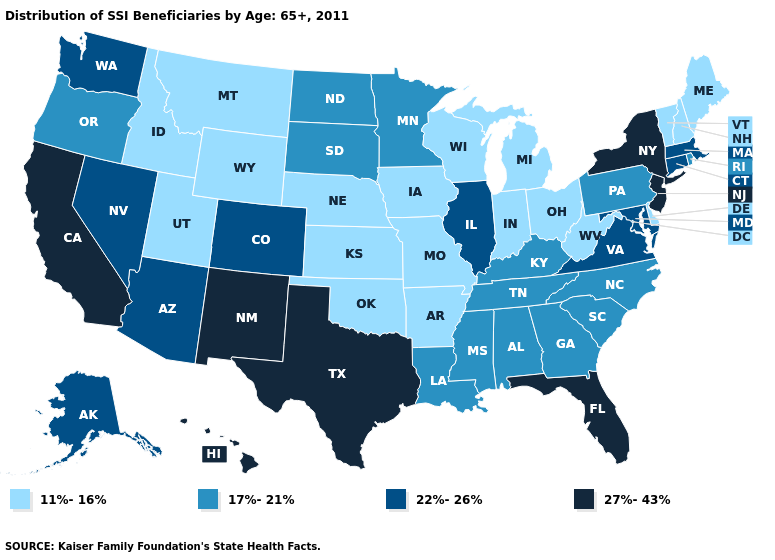What is the highest value in the USA?
Be succinct. 27%-43%. Does Oregon have a lower value than Louisiana?
Concise answer only. No. Does the first symbol in the legend represent the smallest category?
Short answer required. Yes. Name the states that have a value in the range 17%-21%?
Write a very short answer. Alabama, Georgia, Kentucky, Louisiana, Minnesota, Mississippi, North Carolina, North Dakota, Oregon, Pennsylvania, Rhode Island, South Carolina, South Dakota, Tennessee. Name the states that have a value in the range 27%-43%?
Answer briefly. California, Florida, Hawaii, New Jersey, New Mexico, New York, Texas. Name the states that have a value in the range 27%-43%?
Quick response, please. California, Florida, Hawaii, New Jersey, New Mexico, New York, Texas. What is the value of New York?
Short answer required. 27%-43%. What is the value of Oregon?
Quick response, please. 17%-21%. What is the value of Indiana?
Be succinct. 11%-16%. Does Georgia have the same value as Mississippi?
Be succinct. Yes. Does Alabama have the same value as Pennsylvania?
Concise answer only. Yes. Name the states that have a value in the range 22%-26%?
Answer briefly. Alaska, Arizona, Colorado, Connecticut, Illinois, Maryland, Massachusetts, Nevada, Virginia, Washington. Does New Jersey have the lowest value in the Northeast?
Be succinct. No. What is the lowest value in the Northeast?
Concise answer only. 11%-16%. 